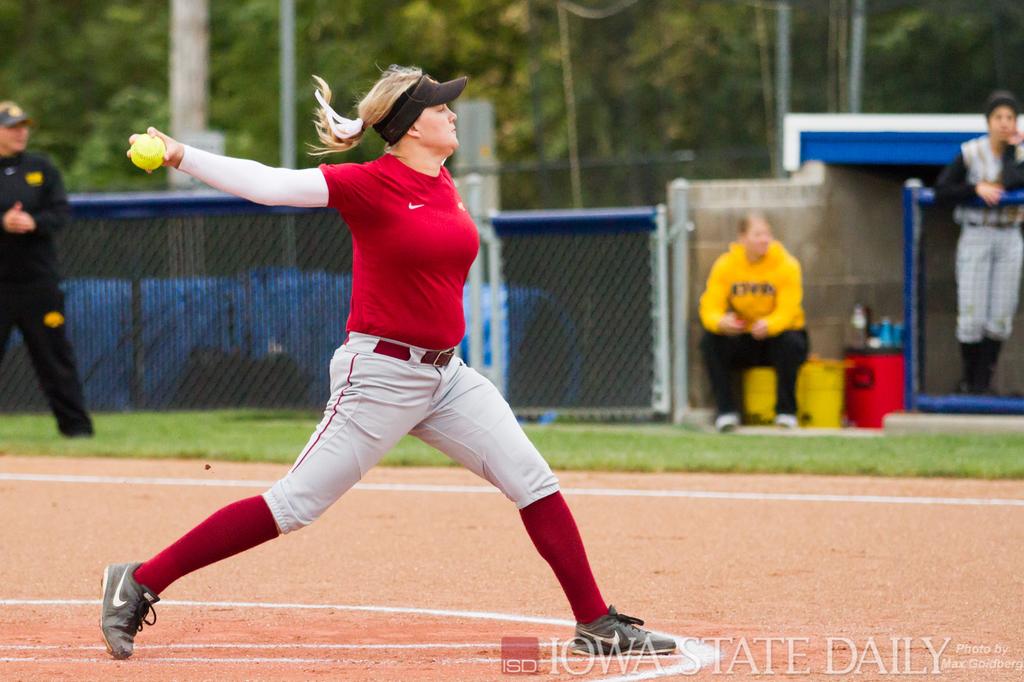What college is this from?
Keep it short and to the point. Iowa state. 